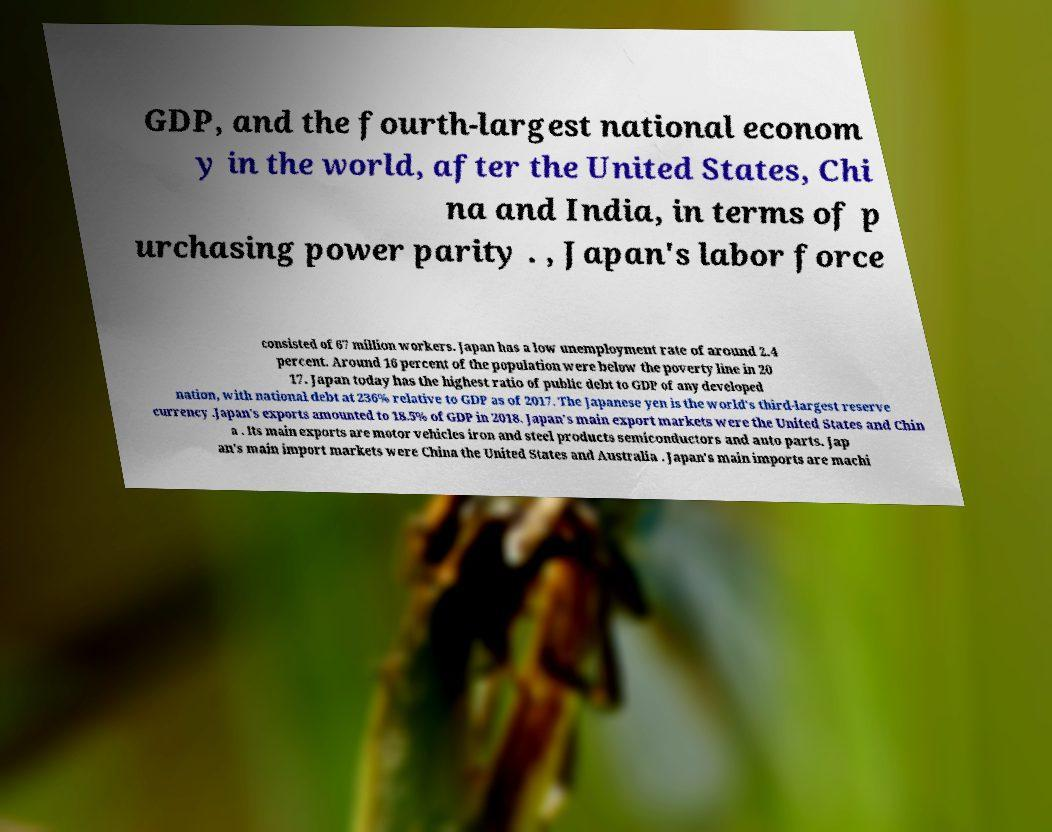Could you assist in decoding the text presented in this image and type it out clearly? GDP, and the fourth-largest national econom y in the world, after the United States, Chi na and India, in terms of p urchasing power parity . , Japan's labor force consisted of 67 million workers. Japan has a low unemployment rate of around 2.4 percent. Around 16 percent of the population were below the poverty line in 20 17. Japan today has the highest ratio of public debt to GDP of any developed nation, with national debt at 236% relative to GDP as of 2017. The Japanese yen is the world's third-largest reserve currency .Japan's exports amounted to 18.5% of GDP in 2018. Japan's main export markets were the United States and Chin a . Its main exports are motor vehicles iron and steel products semiconductors and auto parts. Jap an's main import markets were China the United States and Australia . Japan's main imports are machi 